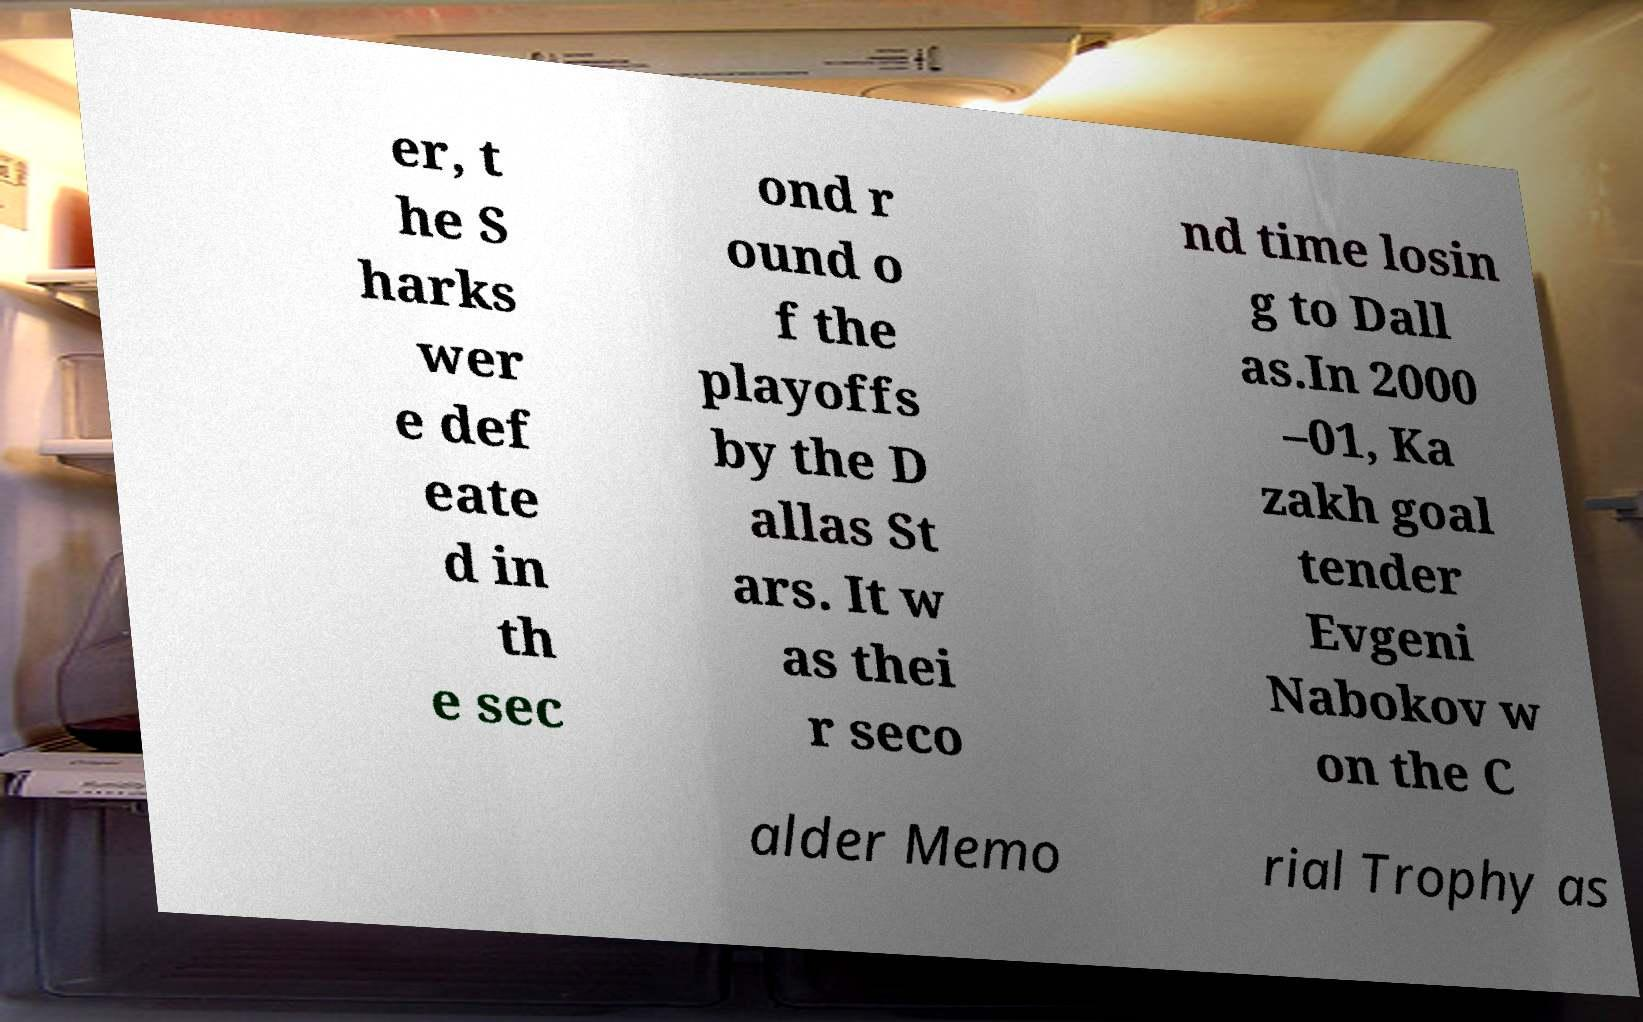For documentation purposes, I need the text within this image transcribed. Could you provide that? er, t he S harks wer e def eate d in th e sec ond r ound o f the playoffs by the D allas St ars. It w as thei r seco nd time losin g to Dall as.In 2000 –01, Ka zakh goal tender Evgeni Nabokov w on the C alder Memo rial Trophy as 